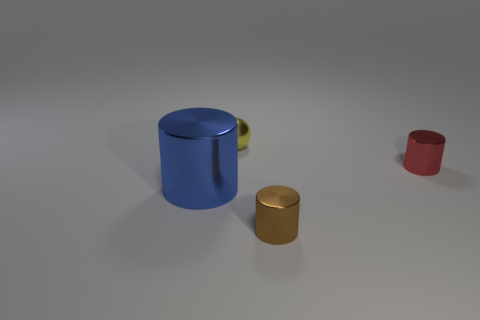Is there a large object that has the same material as the tiny sphere?
Make the answer very short. Yes. What material is the red thing that is the same size as the brown thing?
Make the answer very short. Metal. Are the brown thing and the yellow sphere made of the same material?
Give a very brief answer. Yes. What number of objects are either blue metallic spheres or brown objects?
Your answer should be very brief. 1. The metallic thing that is on the right side of the tiny brown metallic thing has what shape?
Offer a terse response. Cylinder. What is the color of the large thing that is the same material as the tiny ball?
Provide a short and direct response. Blue. What is the shape of the brown shiny object?
Ensure brevity in your answer.  Cylinder. The large blue object that is made of the same material as the tiny yellow thing is what shape?
Your answer should be compact. Cylinder. The yellow thing that is made of the same material as the blue cylinder is what size?
Your answer should be very brief. Small. The small metal object that is behind the large cylinder and to the left of the red shiny thing has what shape?
Your answer should be compact. Sphere. 